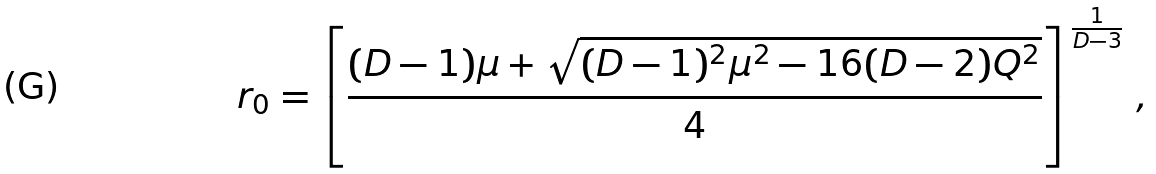<formula> <loc_0><loc_0><loc_500><loc_500>r _ { 0 } = \left [ \frac { ( D - 1 ) \mu + \sqrt { ( D - 1 ) ^ { 2 } \mu ^ { 2 } - 1 6 ( D - 2 ) Q ^ { 2 } } } { 4 } \right ] ^ { \frac { 1 } { D - 3 } } \, ,</formula> 